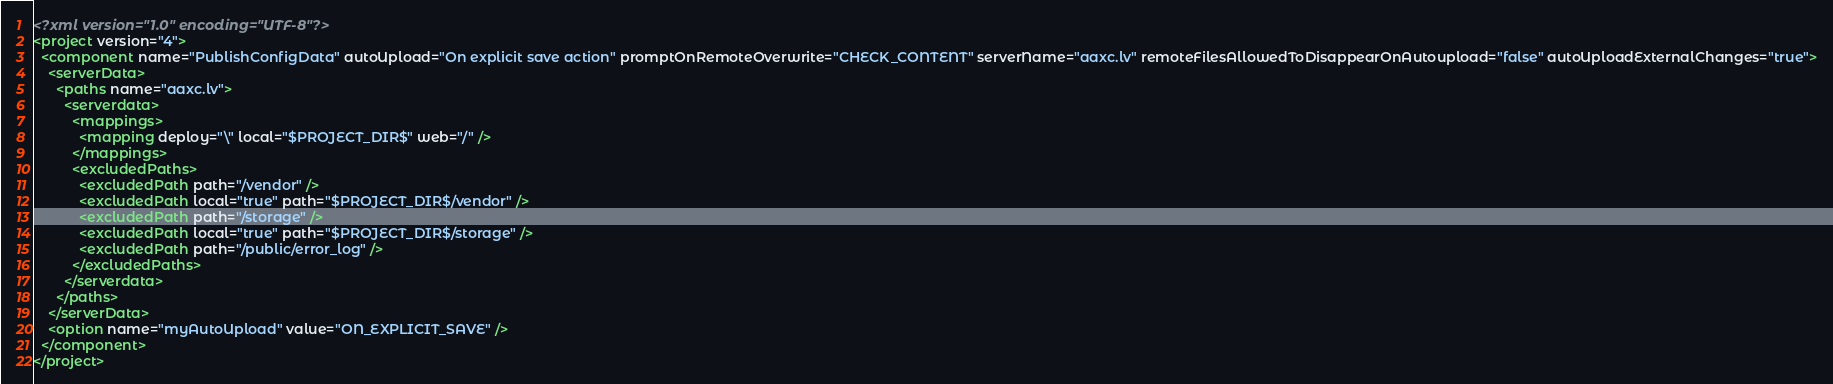<code> <loc_0><loc_0><loc_500><loc_500><_XML_><?xml version="1.0" encoding="UTF-8"?>
<project version="4">
  <component name="PublishConfigData" autoUpload="On explicit save action" promptOnRemoteOverwrite="CHECK_CONTENT" serverName="aaxc.lv" remoteFilesAllowedToDisappearOnAutoupload="false" autoUploadExternalChanges="true">
    <serverData>
      <paths name="aaxc.lv">
        <serverdata>
          <mappings>
            <mapping deploy="\" local="$PROJECT_DIR$" web="/" />
          </mappings>
          <excludedPaths>
            <excludedPath path="/vendor" />
            <excludedPath local="true" path="$PROJECT_DIR$/vendor" />
            <excludedPath path="/storage" />
            <excludedPath local="true" path="$PROJECT_DIR$/storage" />
            <excludedPath path="/public/error_log" />
          </excludedPaths>
        </serverdata>
      </paths>
    </serverData>
    <option name="myAutoUpload" value="ON_EXPLICIT_SAVE" />
  </component>
</project></code> 